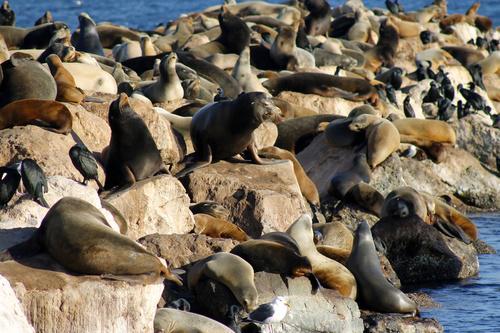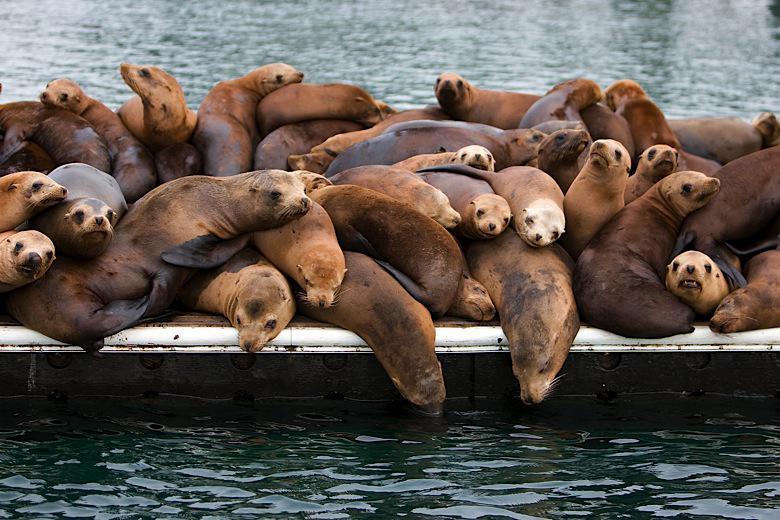The first image is the image on the left, the second image is the image on the right. Assess this claim about the two images: "Seals are in various poses atop large rocks that extend out into the water, with water on both sides, in one image.". Correct or not? Answer yes or no. Yes. 